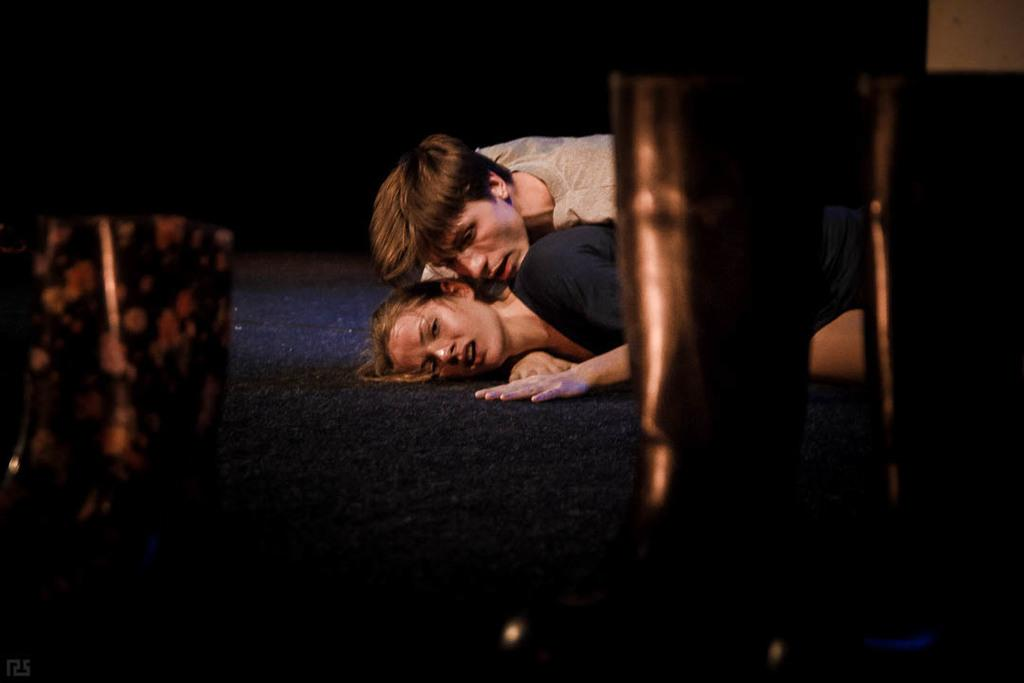Who are the people in the image? There is a girl and a boy in the image. What are they doing in the image? The girl and boy are lying on a flooring mat. How are they positioned on the mat? They are lying on each other. What type of acoustics can be heard from the actor in the image? There is no actor present in the image, and therefore no acoustics can be heard. 